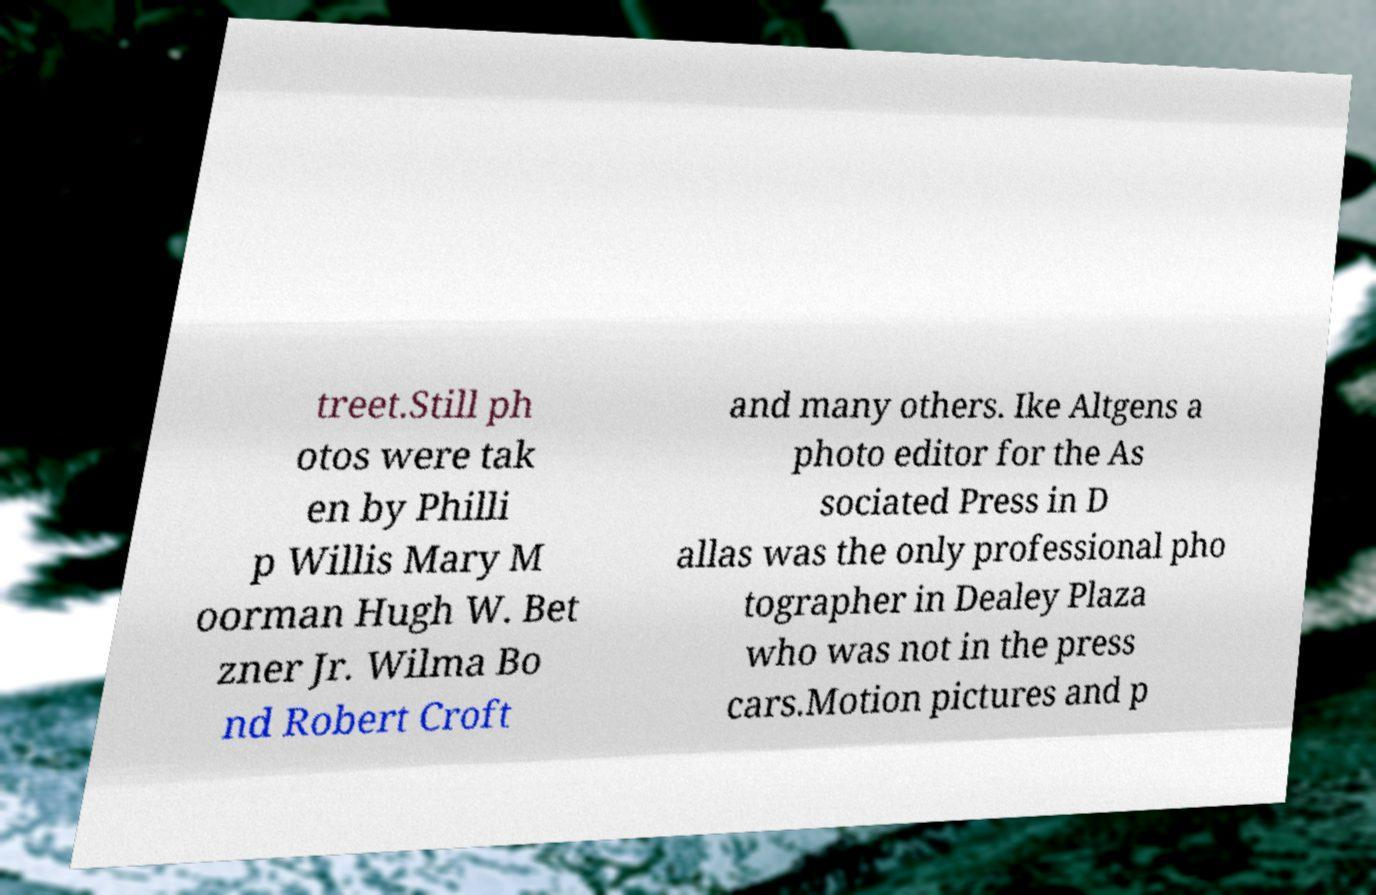Please read and relay the text visible in this image. What does it say? treet.Still ph otos were tak en by Philli p Willis Mary M oorman Hugh W. Bet zner Jr. Wilma Bo nd Robert Croft and many others. Ike Altgens a photo editor for the As sociated Press in D allas was the only professional pho tographer in Dealey Plaza who was not in the press cars.Motion pictures and p 